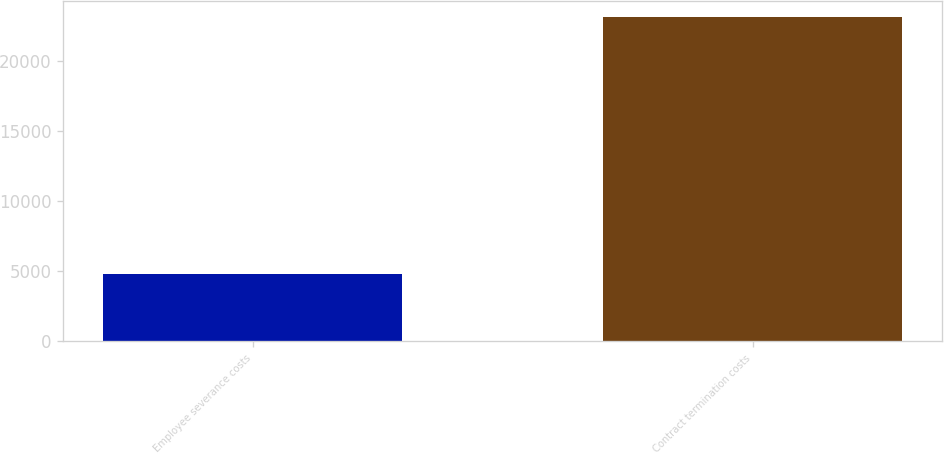Convert chart. <chart><loc_0><loc_0><loc_500><loc_500><bar_chart><fcel>Employee severance costs<fcel>Contract termination costs<nl><fcel>4807<fcel>23113<nl></chart> 